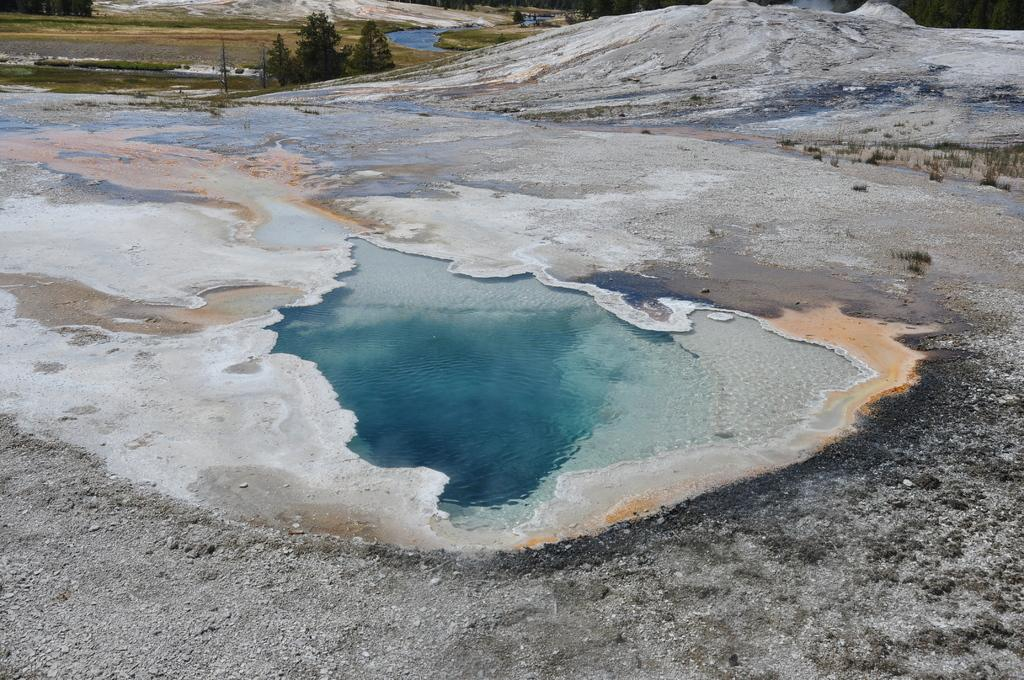What is the primary element visible in the image? There is water in the image. What type of vegetation can be seen in the image? There are trees visible at the top of the image. What is located on the right side of the image? There is a white object on the land on the right side of the image. What type of terrain is visible at the bottom of the image? There are stones visible at the bottom of the image. What type of wall can be seen in the image? There is no wall present in the image. What type of minister is depicted in the image? There is no minister depicted in the image. 